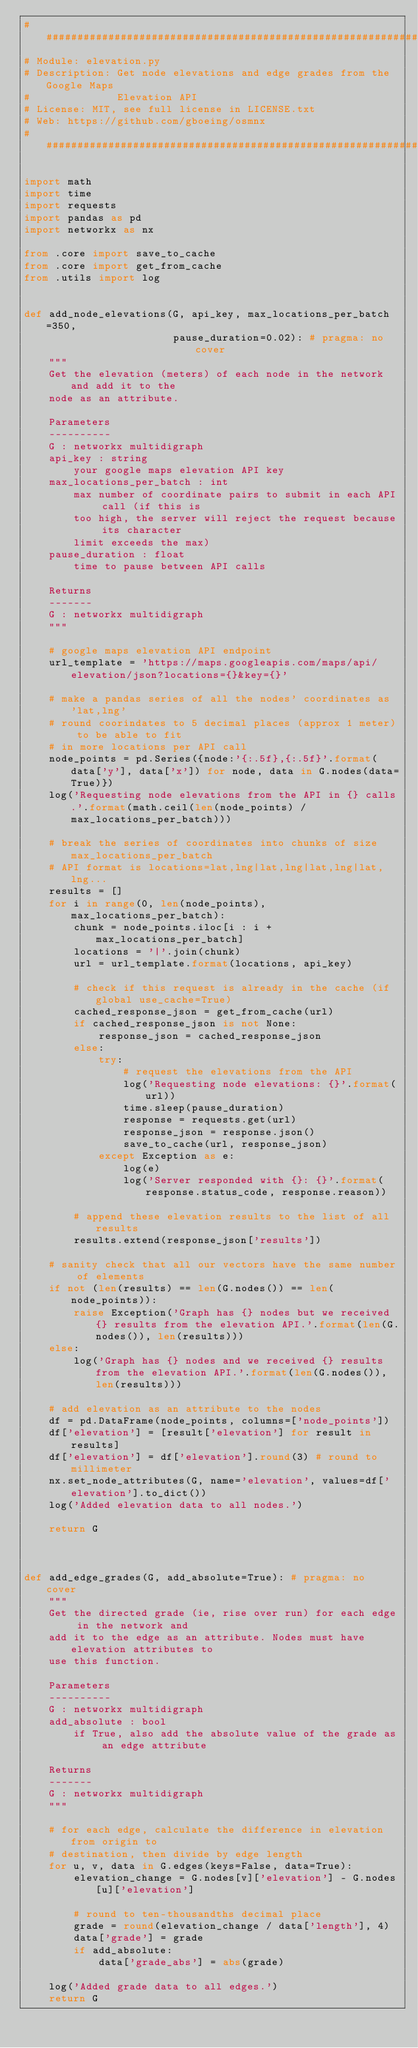Convert code to text. <code><loc_0><loc_0><loc_500><loc_500><_Python_>################################################################################
# Module: elevation.py
# Description: Get node elevations and edge grades from the Google Maps
#              Elevation API
# License: MIT, see full license in LICENSE.txt
# Web: https://github.com/gboeing/osmnx
################################################################################

import math
import time
import requests
import pandas as pd
import networkx as nx

from .core import save_to_cache
from .core import get_from_cache
from .utils import log


def add_node_elevations(G, api_key, max_locations_per_batch=350,
                        pause_duration=0.02): # pragma: no cover
    """
    Get the elevation (meters) of each node in the network and add it to the
    node as an attribute.

    Parameters
    ----------
    G : networkx multidigraph
    api_key : string
        your google maps elevation API key
    max_locations_per_batch : int
        max number of coordinate pairs to submit in each API call (if this is
        too high, the server will reject the request because its character
        limit exceeds the max)
    pause_duration : float
        time to pause between API calls

    Returns
    -------
    G : networkx multidigraph
    """

    # google maps elevation API endpoint
    url_template = 'https://maps.googleapis.com/maps/api/elevation/json?locations={}&key={}'

    # make a pandas series of all the nodes' coordinates as 'lat,lng'
    # round coorindates to 5 decimal places (approx 1 meter) to be able to fit
    # in more locations per API call
    node_points = pd.Series({node:'{:.5f},{:.5f}'.format(data['y'], data['x']) for node, data in G.nodes(data=True)})
    log('Requesting node elevations from the API in {} calls.'.format(math.ceil(len(node_points) / max_locations_per_batch)))

    # break the series of coordinates into chunks of size max_locations_per_batch
    # API format is locations=lat,lng|lat,lng|lat,lng|lat,lng...
    results = []
    for i in range(0, len(node_points), max_locations_per_batch):
        chunk = node_points.iloc[i : i + max_locations_per_batch]
        locations = '|'.join(chunk)
        url = url_template.format(locations, api_key)

        # check if this request is already in the cache (if global use_cache=True)
        cached_response_json = get_from_cache(url)
        if cached_response_json is not None:
            response_json = cached_response_json
        else:
            try:
                # request the elevations from the API
                log('Requesting node elevations: {}'.format(url))
                time.sleep(pause_duration)
                response = requests.get(url)
                response_json = response.json()
                save_to_cache(url, response_json)
            except Exception as e:
                log(e)
                log('Server responded with {}: {}'.format(response.status_code, response.reason))

        # append these elevation results to the list of all results
        results.extend(response_json['results'])

    # sanity check that all our vectors have the same number of elements
    if not (len(results) == len(G.nodes()) == len(node_points)):
        raise Exception('Graph has {} nodes but we received {} results from the elevation API.'.format(len(G.nodes()), len(results)))
    else:
        log('Graph has {} nodes and we received {} results from the elevation API.'.format(len(G.nodes()), len(results)))

    # add elevation as an attribute to the nodes
    df = pd.DataFrame(node_points, columns=['node_points'])
    df['elevation'] = [result['elevation'] for result in results]
    df['elevation'] = df['elevation'].round(3) # round to millimeter
    nx.set_node_attributes(G, name='elevation', values=df['elevation'].to_dict())
    log('Added elevation data to all nodes.')

    return G



def add_edge_grades(G, add_absolute=True): # pragma: no cover
    """
    Get the directed grade (ie, rise over run) for each edge in the network and
    add it to the edge as an attribute. Nodes must have elevation attributes to
    use this function.

    Parameters
    ----------
    G : networkx multidigraph
    add_absolute : bool
        if True, also add the absolute value of the grade as an edge attribute

    Returns
    -------
    G : networkx multidigraph
    """

    # for each edge, calculate the difference in elevation from origin to
    # destination, then divide by edge length
    for u, v, data in G.edges(keys=False, data=True):
        elevation_change = G.nodes[v]['elevation'] - G.nodes[u]['elevation']
        
        # round to ten-thousandths decimal place
        grade = round(elevation_change / data['length'], 4)
        data['grade'] = grade
        if add_absolute:
            data['grade_abs'] = abs(grade)

    log('Added grade data to all edges.')
    return G
</code> 